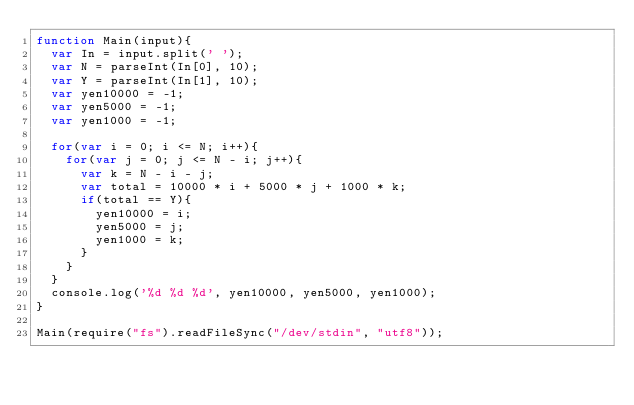<code> <loc_0><loc_0><loc_500><loc_500><_JavaScript_>function Main(input){
  var In = input.split(' ');
  var N = parseInt(In[0], 10);
  var Y = parseInt(In[1], 10);
  var yen10000 = -1;
  var yen5000 = -1;
  var yen1000 = -1;
  
  for(var i = 0; i <= N; i++){
    for(var j = 0; j <= N - i; j++){
      var k = N - i - j;
      var total = 10000 * i + 5000 * j + 1000 * k;
      if(total == Y){
        yen10000 = i;
        yen5000 = j;
        yen1000 = k;
      }
    }
  }
  console.log('%d %d %d', yen10000, yen5000, yen1000);
}

Main(require("fs").readFileSync("/dev/stdin", "utf8"));</code> 